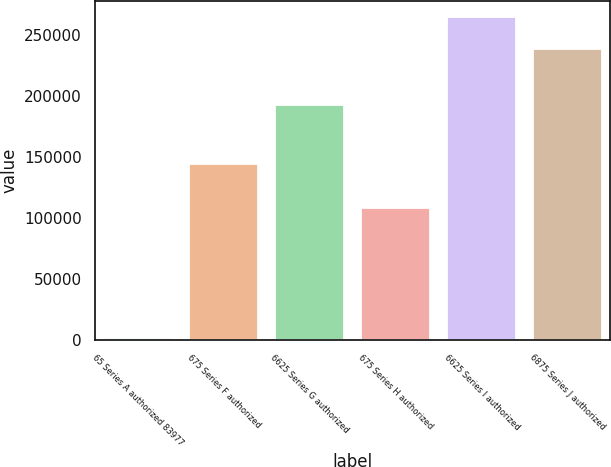Convert chart. <chart><loc_0><loc_0><loc_500><loc_500><bar_chart><fcel>65 Series A authorized 83977<fcel>675 Series F authorized<fcel>6625 Series G authorized<fcel>675 Series H authorized<fcel>6625 Series I authorized<fcel>6875 Series J authorized<nl><fcel>1682<fcel>144720<fcel>193135<fcel>108549<fcel>264912<fcel>238842<nl></chart> 